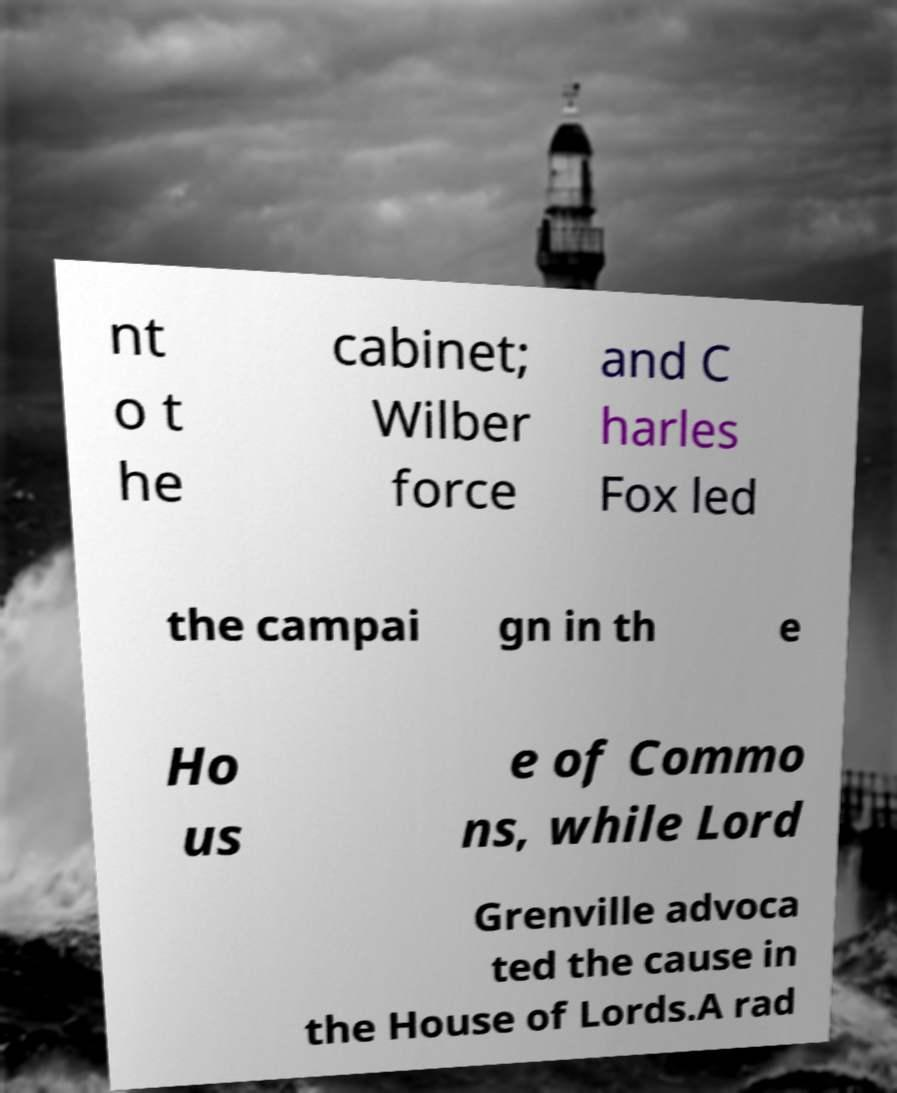Please identify and transcribe the text found in this image. nt o t he cabinet; Wilber force and C harles Fox led the campai gn in th e Ho us e of Commo ns, while Lord Grenville advoca ted the cause in the House of Lords.A rad 